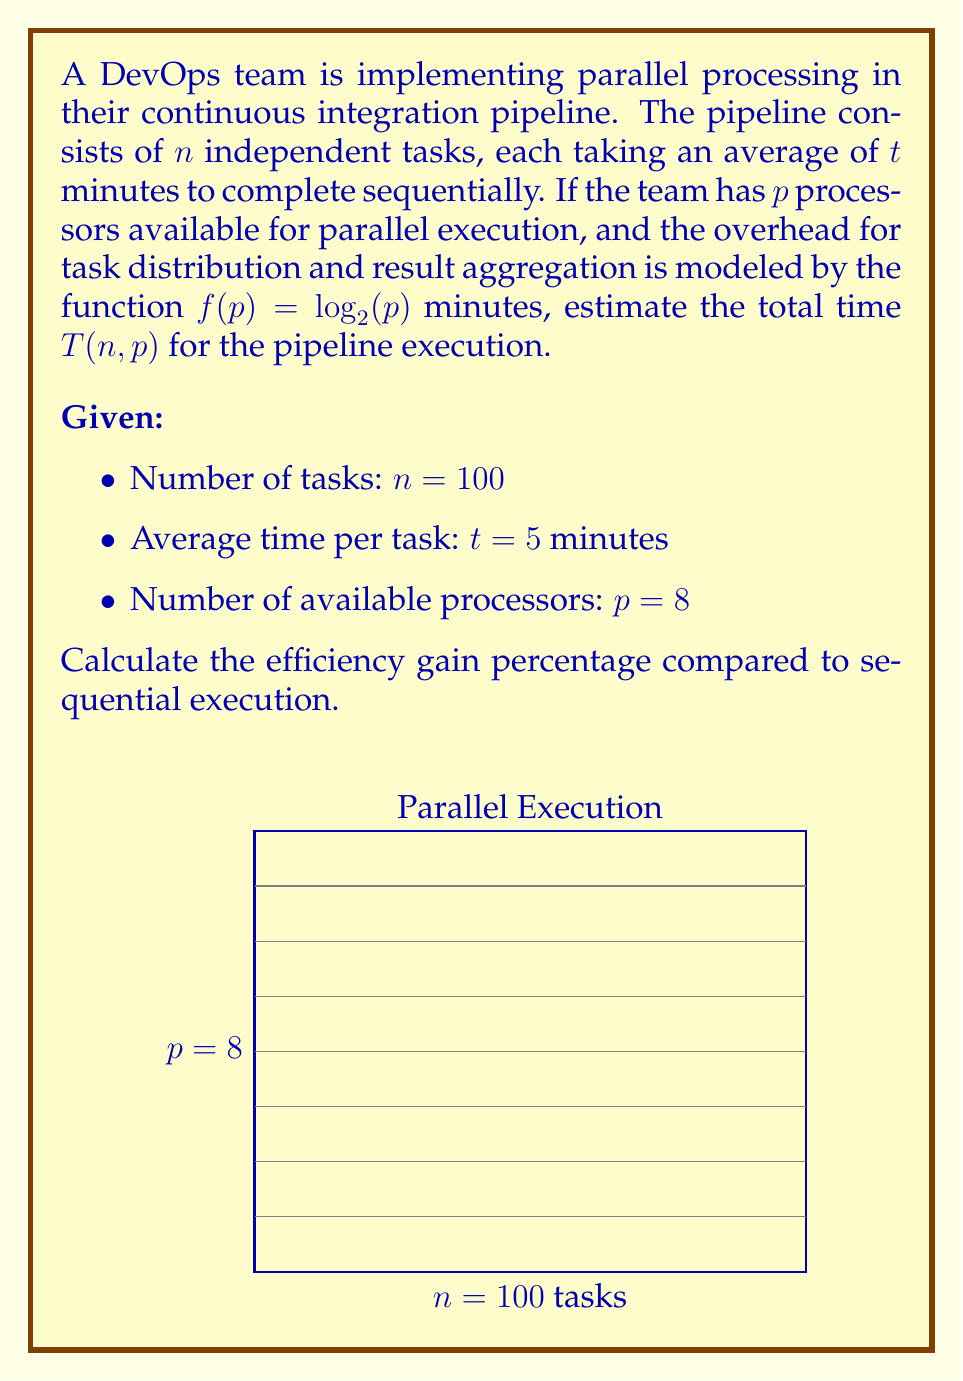Provide a solution to this math problem. Let's approach this step-by-step:

1) In sequential execution, the total time would be:
   $$T_{seq} = n \cdot t = 100 \cdot 5 = 500 \text{ minutes}$$

2) For parallel execution, we need to consider:
   a) The time to distribute tasks across processors
   b) The actual execution time
   c) The time to aggregate results

3) The parallel execution time can be modeled as:
   $$T(n,p) = \frac{n \cdot t}{p} + f(p)$$
   where $f(p) = \log_2(p)$ is the overhead function

4) Substituting the given values:
   $$T(100,8) = \frac{100 \cdot 5}{8} + \log_2(8)$$

5) Simplify:
   $$T(100,8) = \frac{500}{8} + 3 = 62.5 + 3 = 65.5 \text{ minutes}$$

6) To calculate the efficiency gain percentage:
   $$\text{Efficiency Gain} = \frac{T_{seq} - T(n,p)}{T_{seq}} \cdot 100\%$$

7) Substitute the values:
   $$\text{Efficiency Gain} = \frac{500 - 65.5}{500} \cdot 100\% = 0.869 \cdot 100\% = 86.9\%$$

Thus, the efficiency gain from parallel processing in this continuous integration pipeline is approximately 86.9%.
Answer: 86.9% 